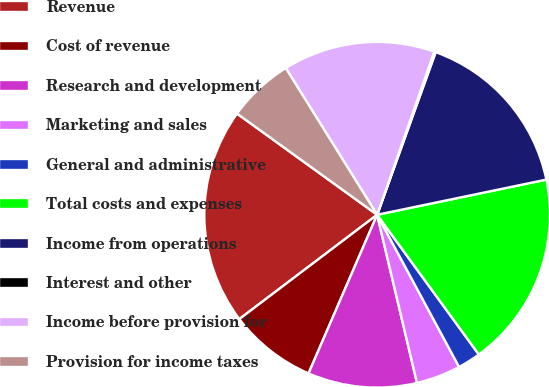Convert chart to OTSL. <chart><loc_0><loc_0><loc_500><loc_500><pie_chart><fcel>Revenue<fcel>Cost of revenue<fcel>Research and development<fcel>Marketing and sales<fcel>General and administrative<fcel>Total costs and expenses<fcel>Income from operations<fcel>Interest and other<fcel>Income before provision for<fcel>Provision for income taxes<nl><fcel>20.27%<fcel>8.19%<fcel>10.2%<fcel>4.16%<fcel>2.15%<fcel>18.25%<fcel>16.24%<fcel>0.14%<fcel>14.23%<fcel>6.18%<nl></chart> 